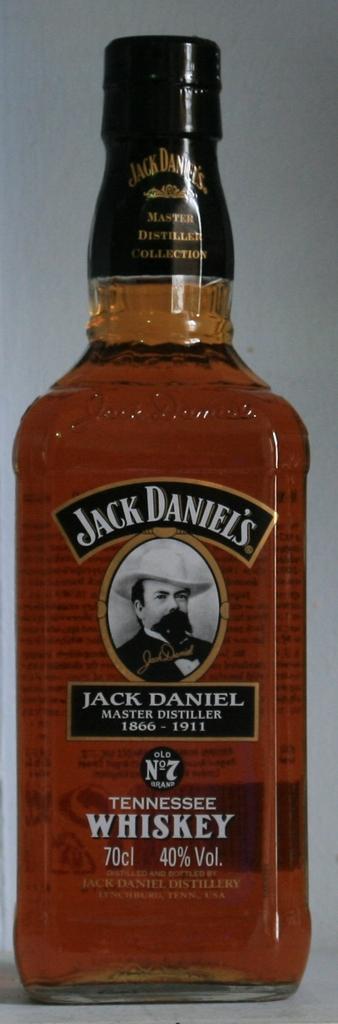What us state is this whiskey from?
Give a very brief answer. Tennessee. What brand of whiskey?
Give a very brief answer. Jack daniel's. 